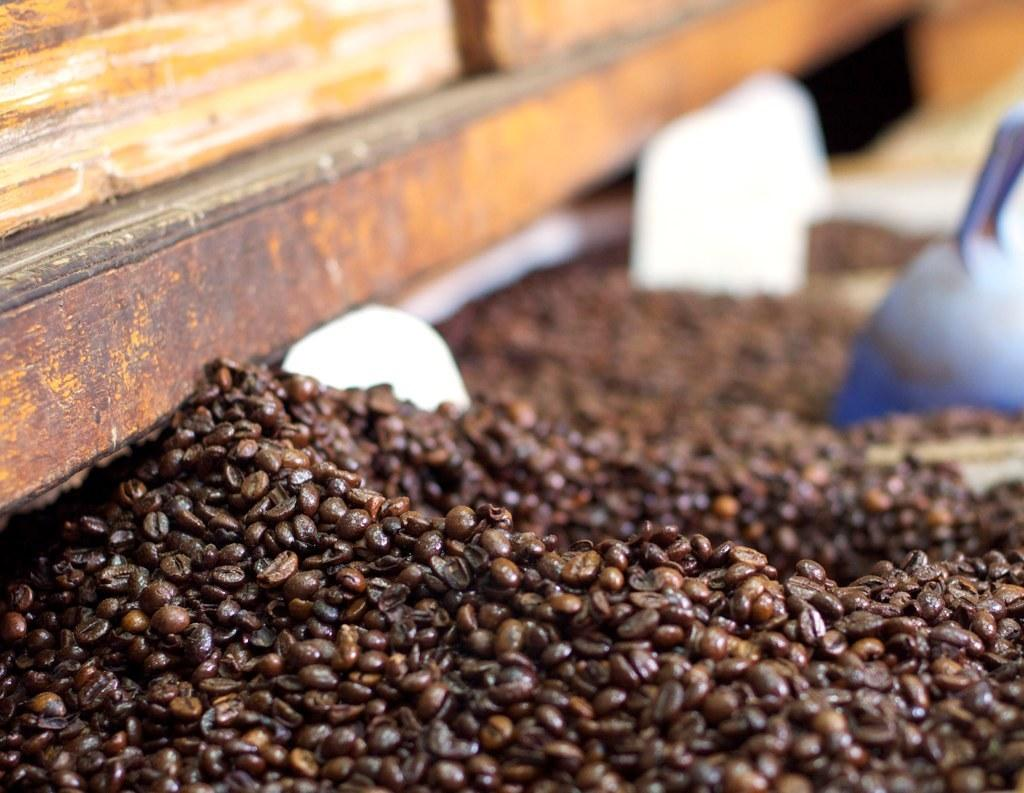What type of beans are in the image? There are coffee beans in the image. Can you describe any utensils visible in the image? The soup spoon is visible in the image, although it may be blurry. What type of prose can be heard in the background of the image? There is no prose or any audible content in the image, as it is a still image. 